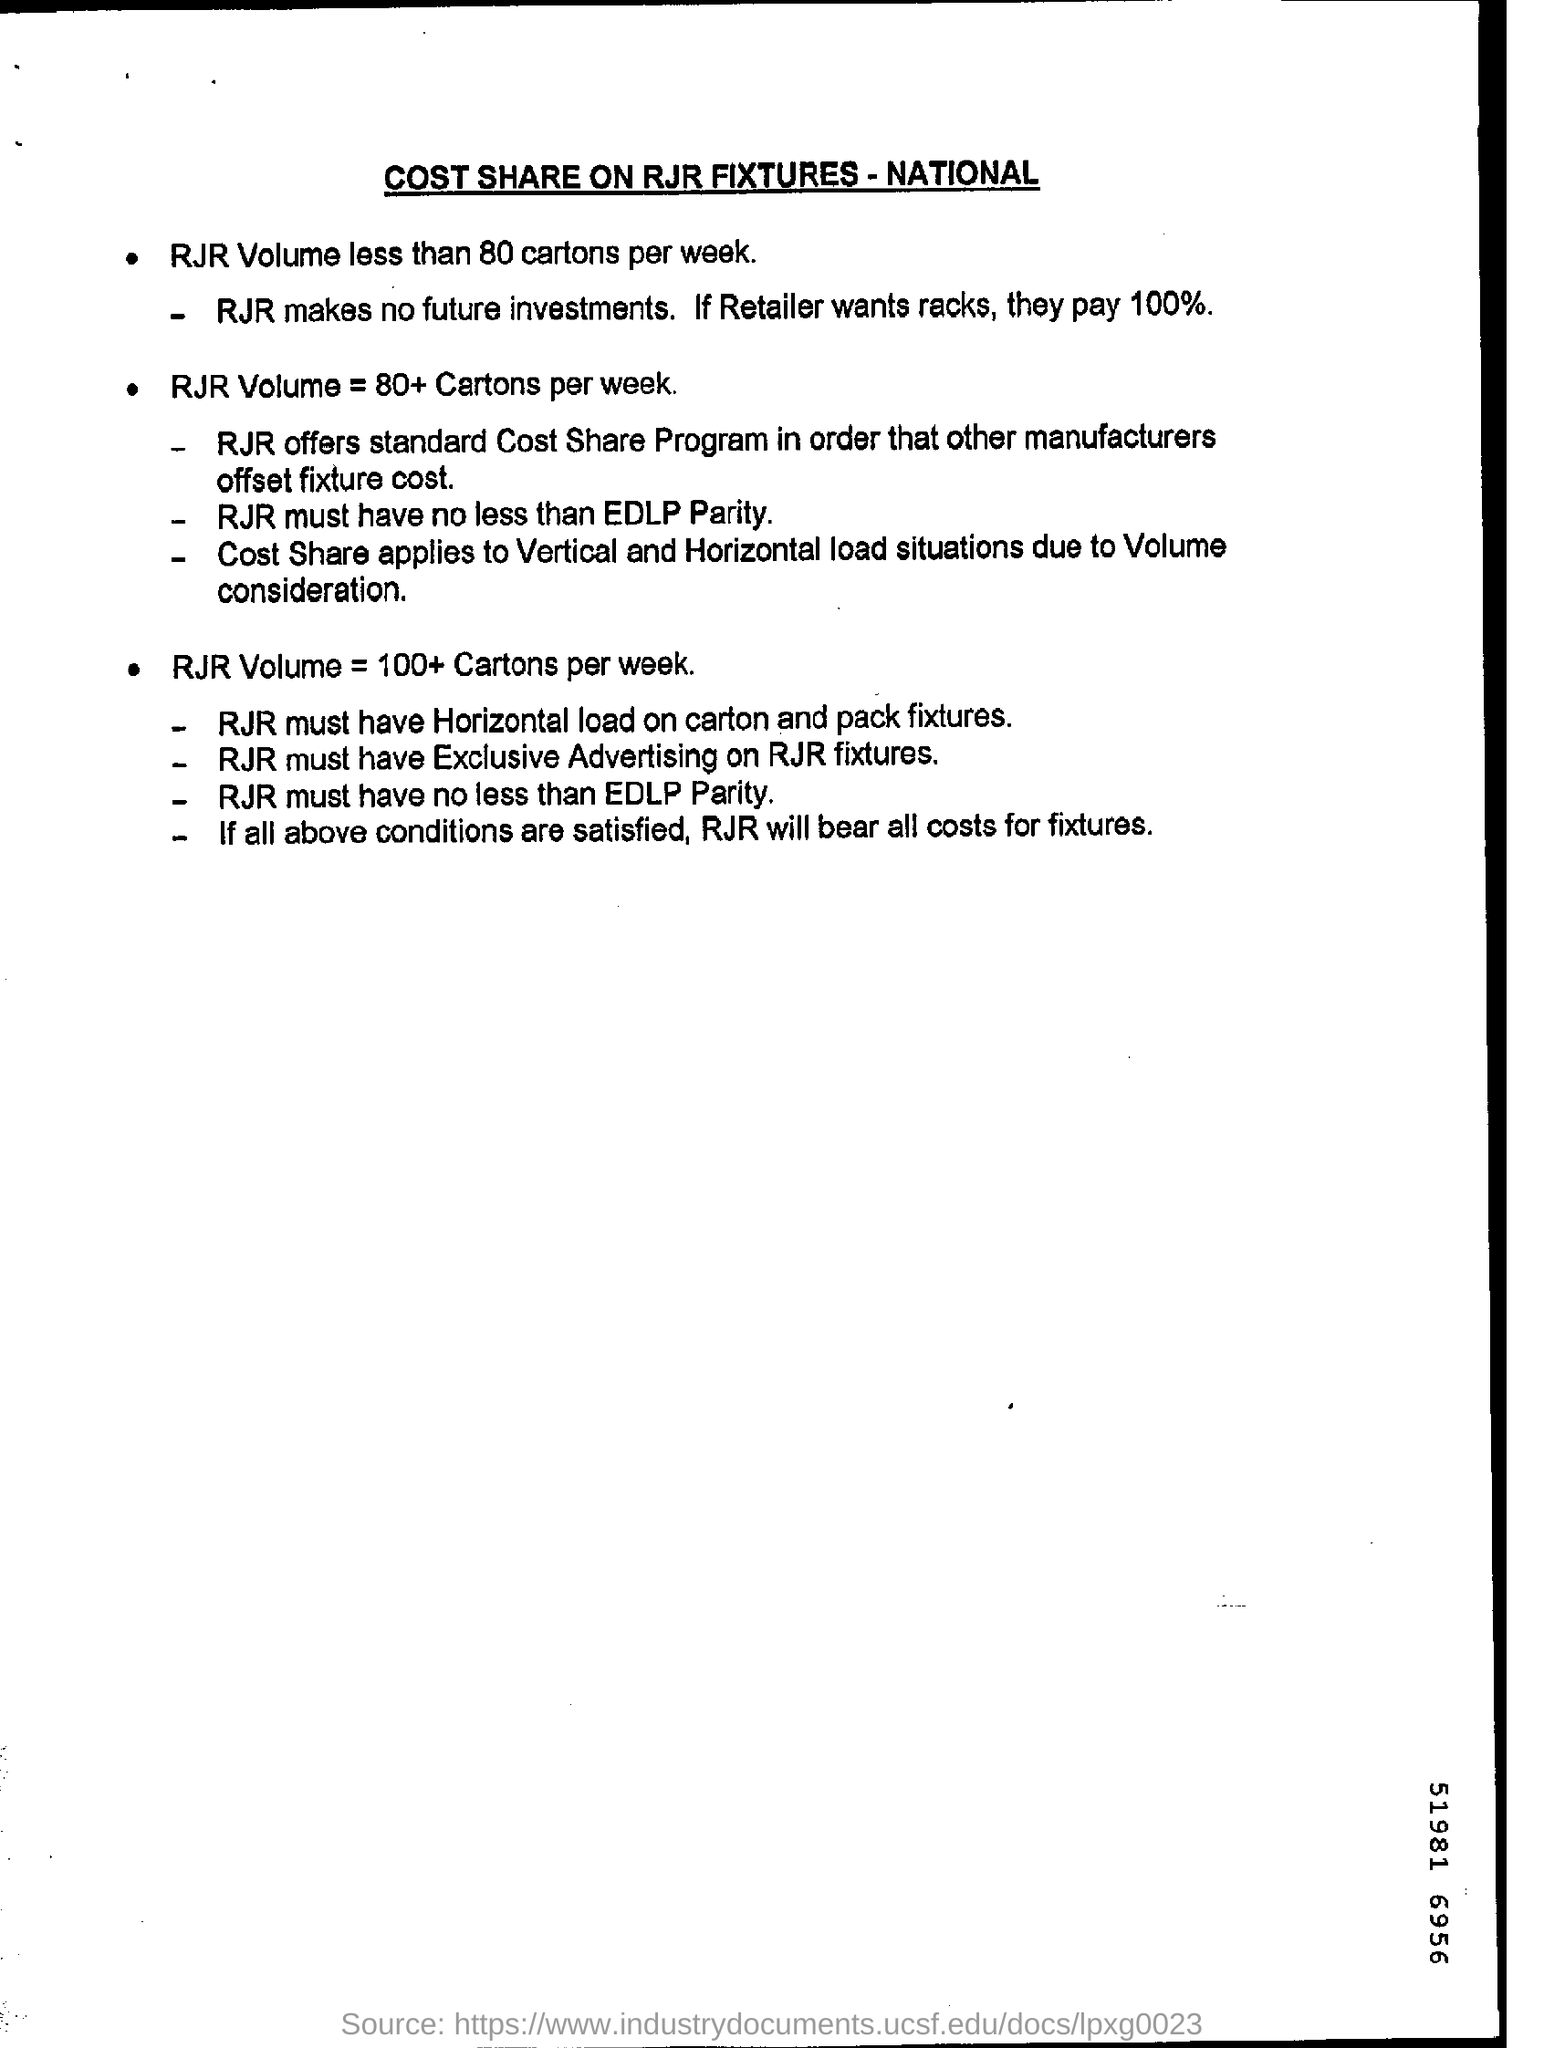How much % will retailer have to pay if they wants racks ?
Provide a short and direct response. 100%. 